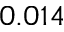<formula> <loc_0><loc_0><loc_500><loc_500>0 . 0 1 4</formula> 